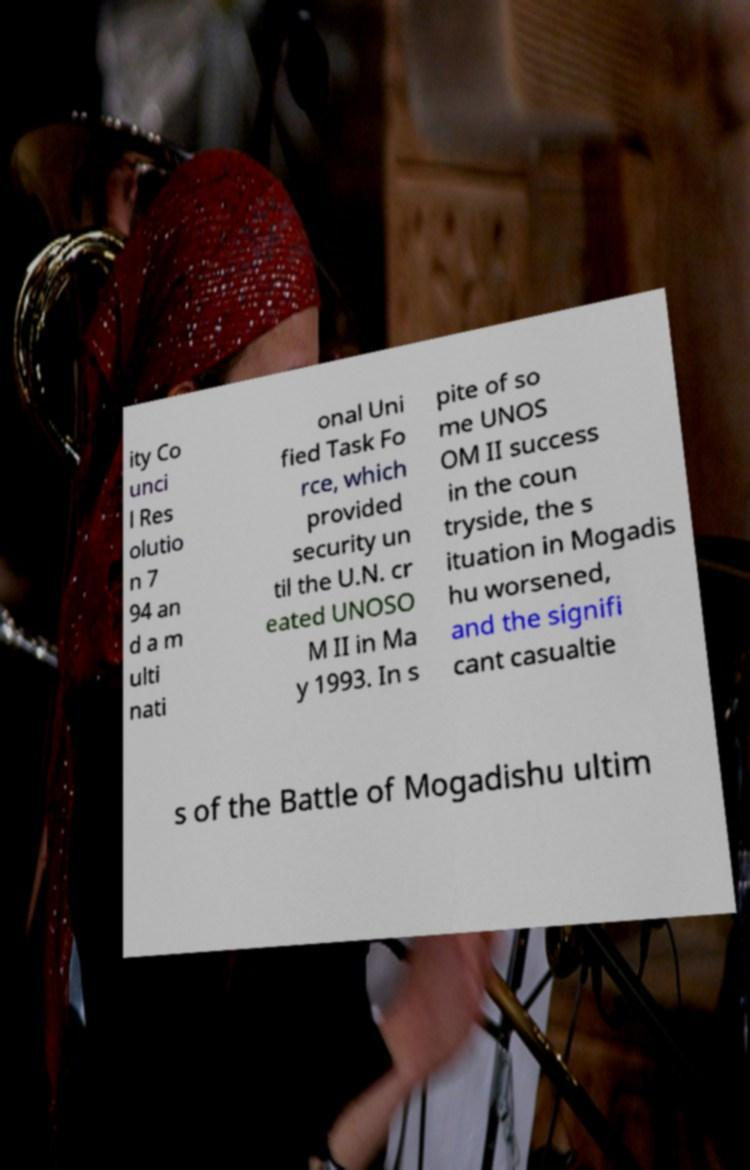I need the written content from this picture converted into text. Can you do that? ity Co unci l Res olutio n 7 94 an d a m ulti nati onal Uni fied Task Fo rce, which provided security un til the U.N. cr eated UNOSO M II in Ma y 1993. In s pite of so me UNOS OM II success in the coun tryside, the s ituation in Mogadis hu worsened, and the signifi cant casualtie s of the Battle of Mogadishu ultim 